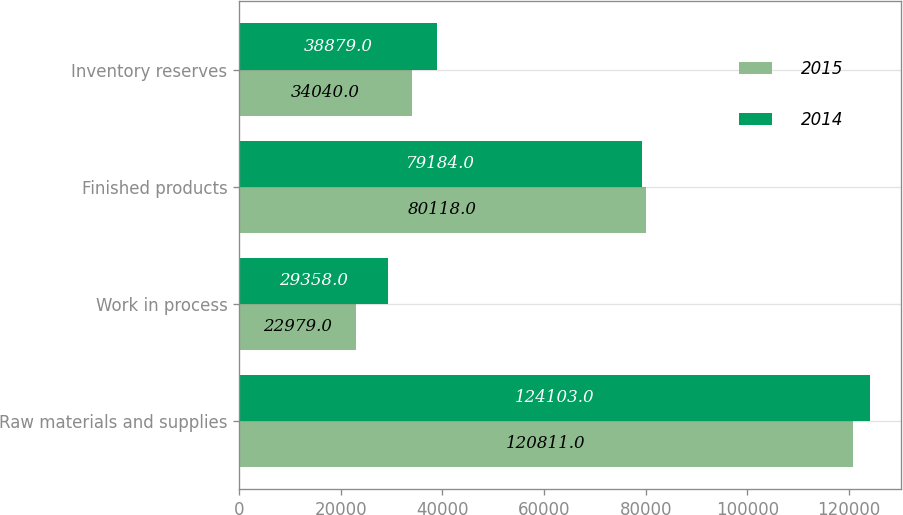<chart> <loc_0><loc_0><loc_500><loc_500><stacked_bar_chart><ecel><fcel>Raw materials and supplies<fcel>Work in process<fcel>Finished products<fcel>Inventory reserves<nl><fcel>2015<fcel>120811<fcel>22979<fcel>80118<fcel>34040<nl><fcel>2014<fcel>124103<fcel>29358<fcel>79184<fcel>38879<nl></chart> 